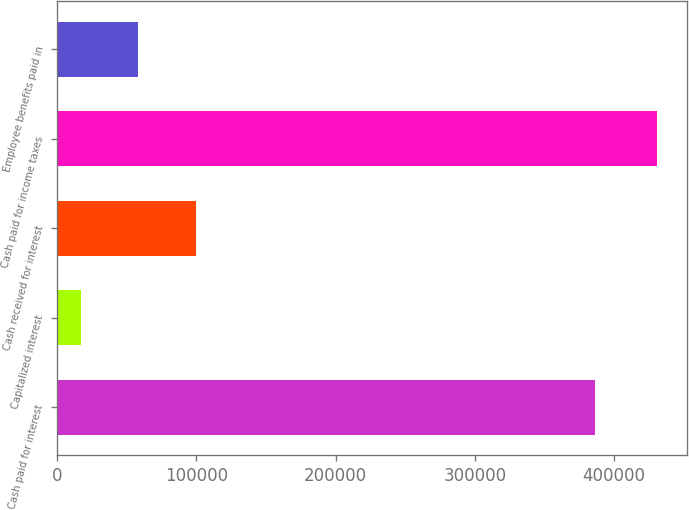<chart> <loc_0><loc_0><loc_500><loc_500><bar_chart><fcel>Cash paid for interest<fcel>Capitalized interest<fcel>Cash received for interest<fcel>Cash paid for income taxes<fcel>Employee benefits paid in<nl><fcel>385936<fcel>16880<fcel>99585.6<fcel>430408<fcel>58232.8<nl></chart> 